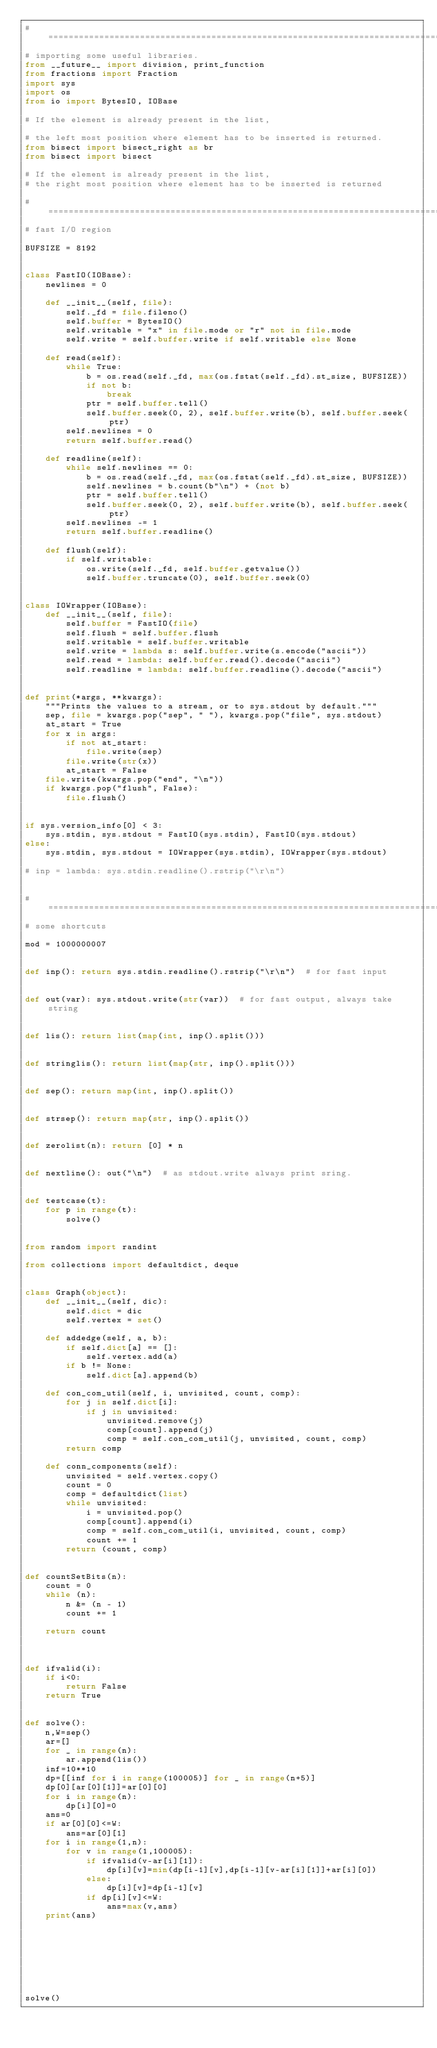Convert code to text. <code><loc_0><loc_0><loc_500><loc_500><_Python_># ===============================================================================================
# importing some useful libraries.
from __future__ import division, print_function
from fractions import Fraction
import sys
import os
from io import BytesIO, IOBase

# If the element is already present in the list,

# the left most position where element has to be inserted is returned.
from bisect import bisect_right as br
from bisect import bisect

# If the element is already present in the list,
# the right most position where element has to be inserted is returned

# ==============================================================================================
# fast I/O region

BUFSIZE = 8192


class FastIO(IOBase):
    newlines = 0

    def __init__(self, file):
        self._fd = file.fileno()
        self.buffer = BytesIO()
        self.writable = "x" in file.mode or "r" not in file.mode
        self.write = self.buffer.write if self.writable else None

    def read(self):
        while True:
            b = os.read(self._fd, max(os.fstat(self._fd).st_size, BUFSIZE))
            if not b:
                break
            ptr = self.buffer.tell()
            self.buffer.seek(0, 2), self.buffer.write(b), self.buffer.seek(ptr)
        self.newlines = 0
        return self.buffer.read()

    def readline(self):
        while self.newlines == 0:
            b = os.read(self._fd, max(os.fstat(self._fd).st_size, BUFSIZE))
            self.newlines = b.count(b"\n") + (not b)
            ptr = self.buffer.tell()
            self.buffer.seek(0, 2), self.buffer.write(b), self.buffer.seek(ptr)
        self.newlines -= 1
        return self.buffer.readline()

    def flush(self):
        if self.writable:
            os.write(self._fd, self.buffer.getvalue())
            self.buffer.truncate(0), self.buffer.seek(0)


class IOWrapper(IOBase):
    def __init__(self, file):
        self.buffer = FastIO(file)
        self.flush = self.buffer.flush
        self.writable = self.buffer.writable
        self.write = lambda s: self.buffer.write(s.encode("ascii"))
        self.read = lambda: self.buffer.read().decode("ascii")
        self.readline = lambda: self.buffer.readline().decode("ascii")


def print(*args, **kwargs):
    """Prints the values to a stream, or to sys.stdout by default."""
    sep, file = kwargs.pop("sep", " "), kwargs.pop("file", sys.stdout)
    at_start = True
    for x in args:
        if not at_start:
            file.write(sep)
        file.write(str(x))
        at_start = False
    file.write(kwargs.pop("end", "\n"))
    if kwargs.pop("flush", False):
        file.flush()


if sys.version_info[0] < 3:
    sys.stdin, sys.stdout = FastIO(sys.stdin), FastIO(sys.stdout)
else:
    sys.stdin, sys.stdout = IOWrapper(sys.stdin), IOWrapper(sys.stdout)

# inp = lambda: sys.stdin.readline().rstrip("\r\n")


# ===============================================================================================
# some shortcuts

mod = 1000000007


def inp(): return sys.stdin.readline().rstrip("\r\n")  # for fast input


def out(var): sys.stdout.write(str(var))  # for fast output, always take string


def lis(): return list(map(int, inp().split()))


def stringlis(): return list(map(str, inp().split()))


def sep(): return map(int, inp().split())


def strsep(): return map(str, inp().split())


def zerolist(n): return [0] * n


def nextline(): out("\n")  # as stdout.write always print sring.


def testcase(t):
    for p in range(t):
        solve()


from random import randint

from collections import defaultdict, deque


class Graph(object):
    def __init__(self, dic):
        self.dict = dic
        self.vertex = set()

    def addedge(self, a, b):
        if self.dict[a] == []:
            self.vertex.add(a)
        if b != None:
            self.dict[a].append(b)

    def con_com_util(self, i, unvisited, count, comp):
        for j in self.dict[i]:
            if j in unvisited:
                unvisited.remove(j)
                comp[count].append(j)
                comp = self.con_com_util(j, unvisited, count, comp)
        return comp

    def conn_components(self):
        unvisited = self.vertex.copy()
        count = 0
        comp = defaultdict(list)
        while unvisited:
            i = unvisited.pop()
            comp[count].append(i)
            comp = self.con_com_util(i, unvisited, count, comp)
            count += 1
        return (count, comp)


def countSetBits(n):
    count = 0
    while (n):
        n &= (n - 1)
        count += 1

    return count



def ifvalid(i):
    if i<0:
        return False
    return True


def solve():
    n,W=sep()
    ar=[]
    for _ in range(n):
        ar.append(lis())
    inf=10**10
    dp=[[inf for i in range(100005)] for _ in range(n+5)]
    dp[0][ar[0][1]]=ar[0][0]
    for i in range(n):
        dp[i][0]=0
    ans=0
    if ar[0][0]<=W:
        ans=ar[0][1]
    for i in range(1,n):
        for v in range(1,100005):
            if ifvalid(v-ar[i][1]):
                dp[i][v]=min(dp[i-1][v],dp[i-1][v-ar[i][1]]+ar[i][0])
            else:
                dp[i][v]=dp[i-1][v]
            if dp[i][v]<=W:
                ans=max(v,ans)
    print(ans)








solve()
</code> 